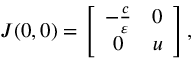Convert formula to latex. <formula><loc_0><loc_0><loc_500><loc_500>\begin{array} { r } { J ( 0 , 0 ) = \left [ { \begin{array} { c c } { - \frac { c } { \varepsilon } } & { 0 } \\ { 0 } & { u } \end{array} } \right ] , } \end{array}</formula> 